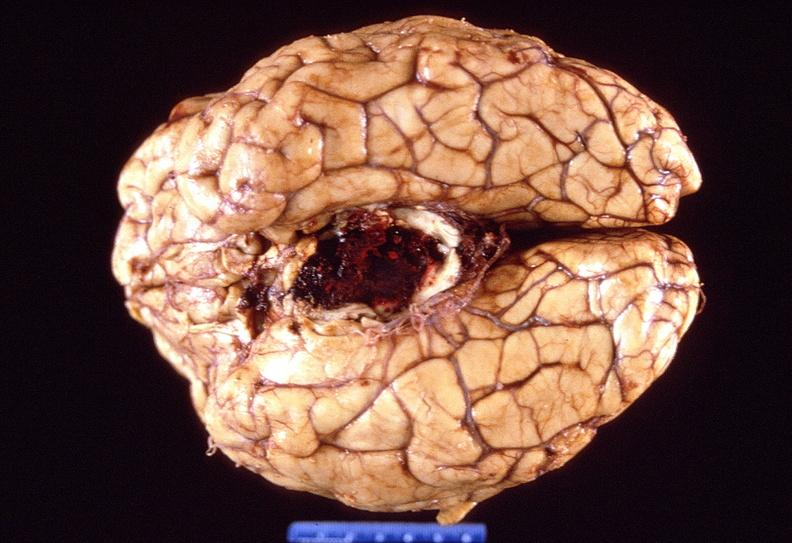what does this image show?
Answer the question using a single word or phrase. Brain 